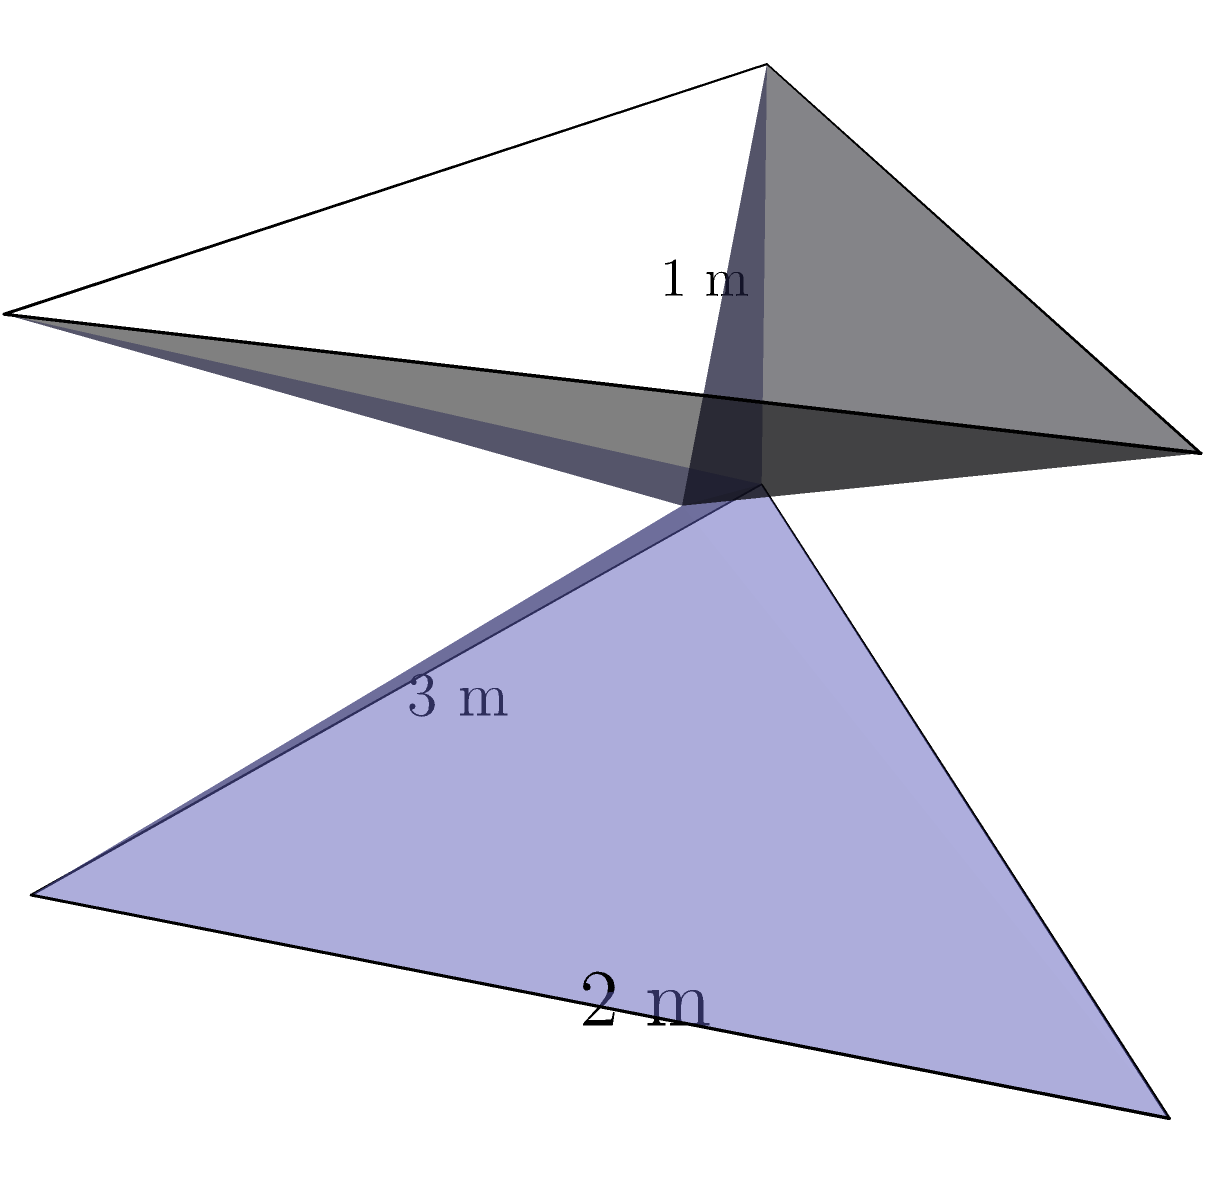A wheelchair-accessible ramp is being designed for a local horror movie theater. The ramp can be modeled as a triangular prism with a base length of 3 meters, width of 2 meters, and height of 1 meter. What is the volume of concrete needed to construct this ramp? To find the volume of the triangular prism, we need to follow these steps:

1. Recall the formula for the volume of a triangular prism:
   $$V = \frac{1}{2} \times l \times w \times h$$
   where $V$ is volume, $l$ is base length, $w$ is width, and $h$ is height.

2. Identify the given dimensions:
   - Base length ($l$) = 3 meters
   - Width ($w$) = 2 meters
   - Height ($h$) = 1 meter

3. Substitute these values into the formula:
   $$V = \frac{1}{2} \times 3 \times 2 \times 1$$

4. Perform the calculation:
   $$V = \frac{1}{2} \times 6 = 3$$

5. Add the unit of measurement (cubic meters):
   $$V = 3 \text{ m}^3$$

Therefore, the volume of concrete needed to construct this wheelchair-accessible ramp is 3 cubic meters.
Answer: $3 \text{ m}^3$ 